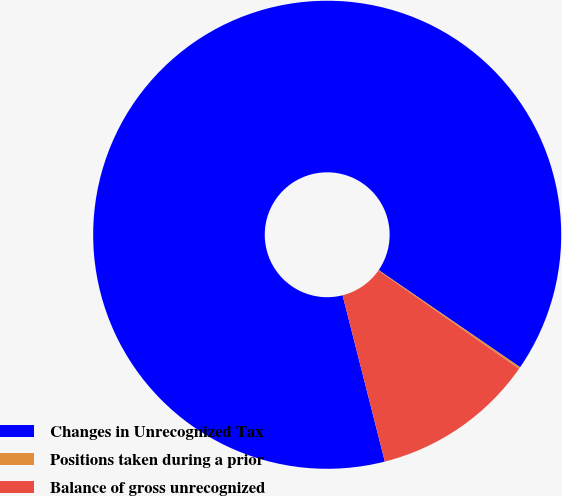Convert chart. <chart><loc_0><loc_0><loc_500><loc_500><pie_chart><fcel>Changes in Unrecognized Tax<fcel>Positions taken during a prior<fcel>Balance of gross unrecognized<nl><fcel>88.54%<fcel>0.13%<fcel>11.33%<nl></chart> 